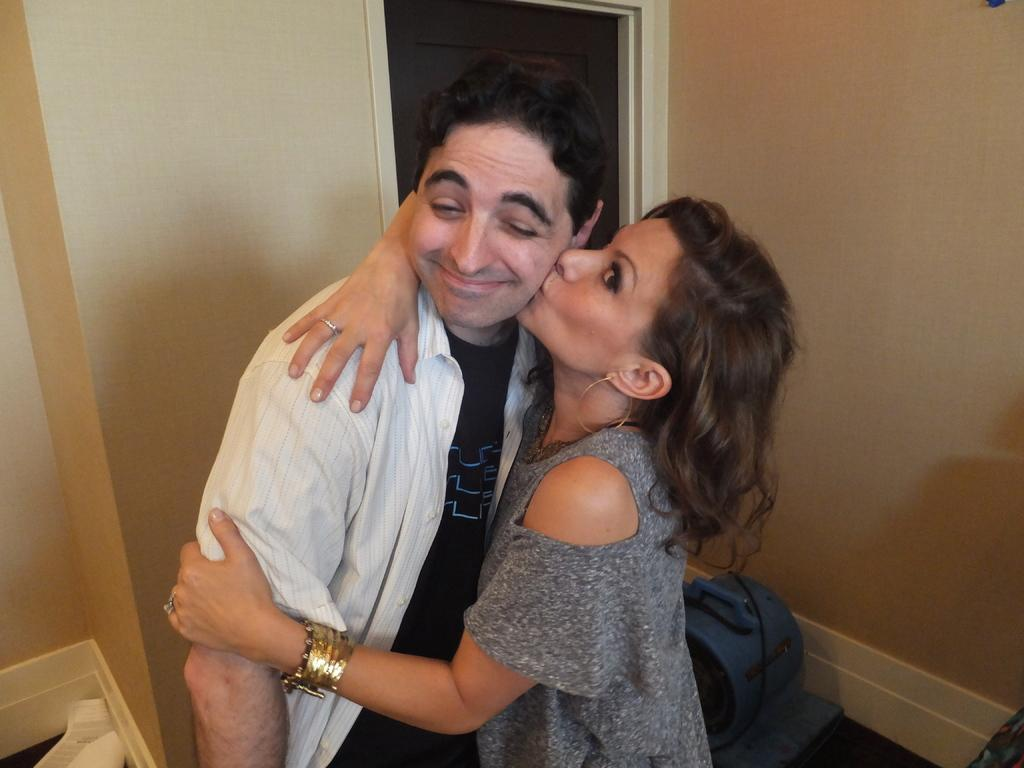Who is present in the image? There is a woman in the image. What is the woman doing in the image? The woman is kissing a man. Where is the man positioned in relation to the woman? The man is beside the woman. What can be seen in the background of the image? There is a wall in the background of the image. What is located at the bottom of the image? There is a motor at the bottom of the image. What type of flowers can be seen growing on the wall in the image? There are no flowers visible in the image; the background only shows a wall. 